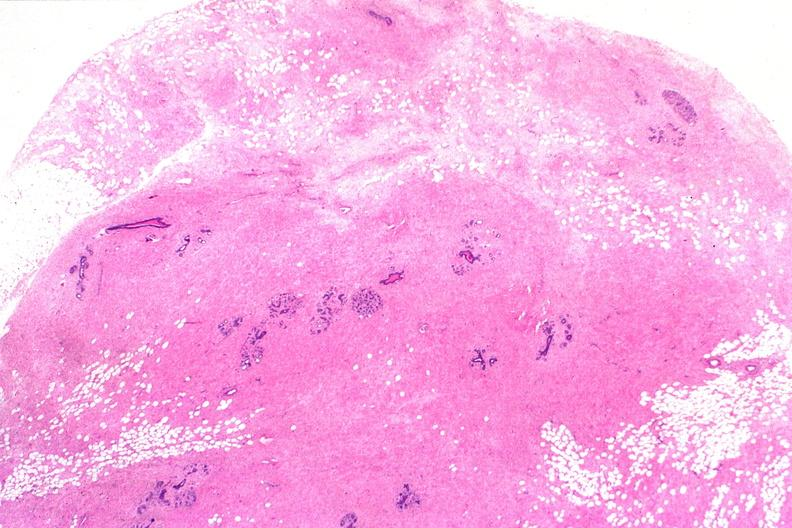does yellow color show normal breast?
Answer the question using a single word or phrase. No 